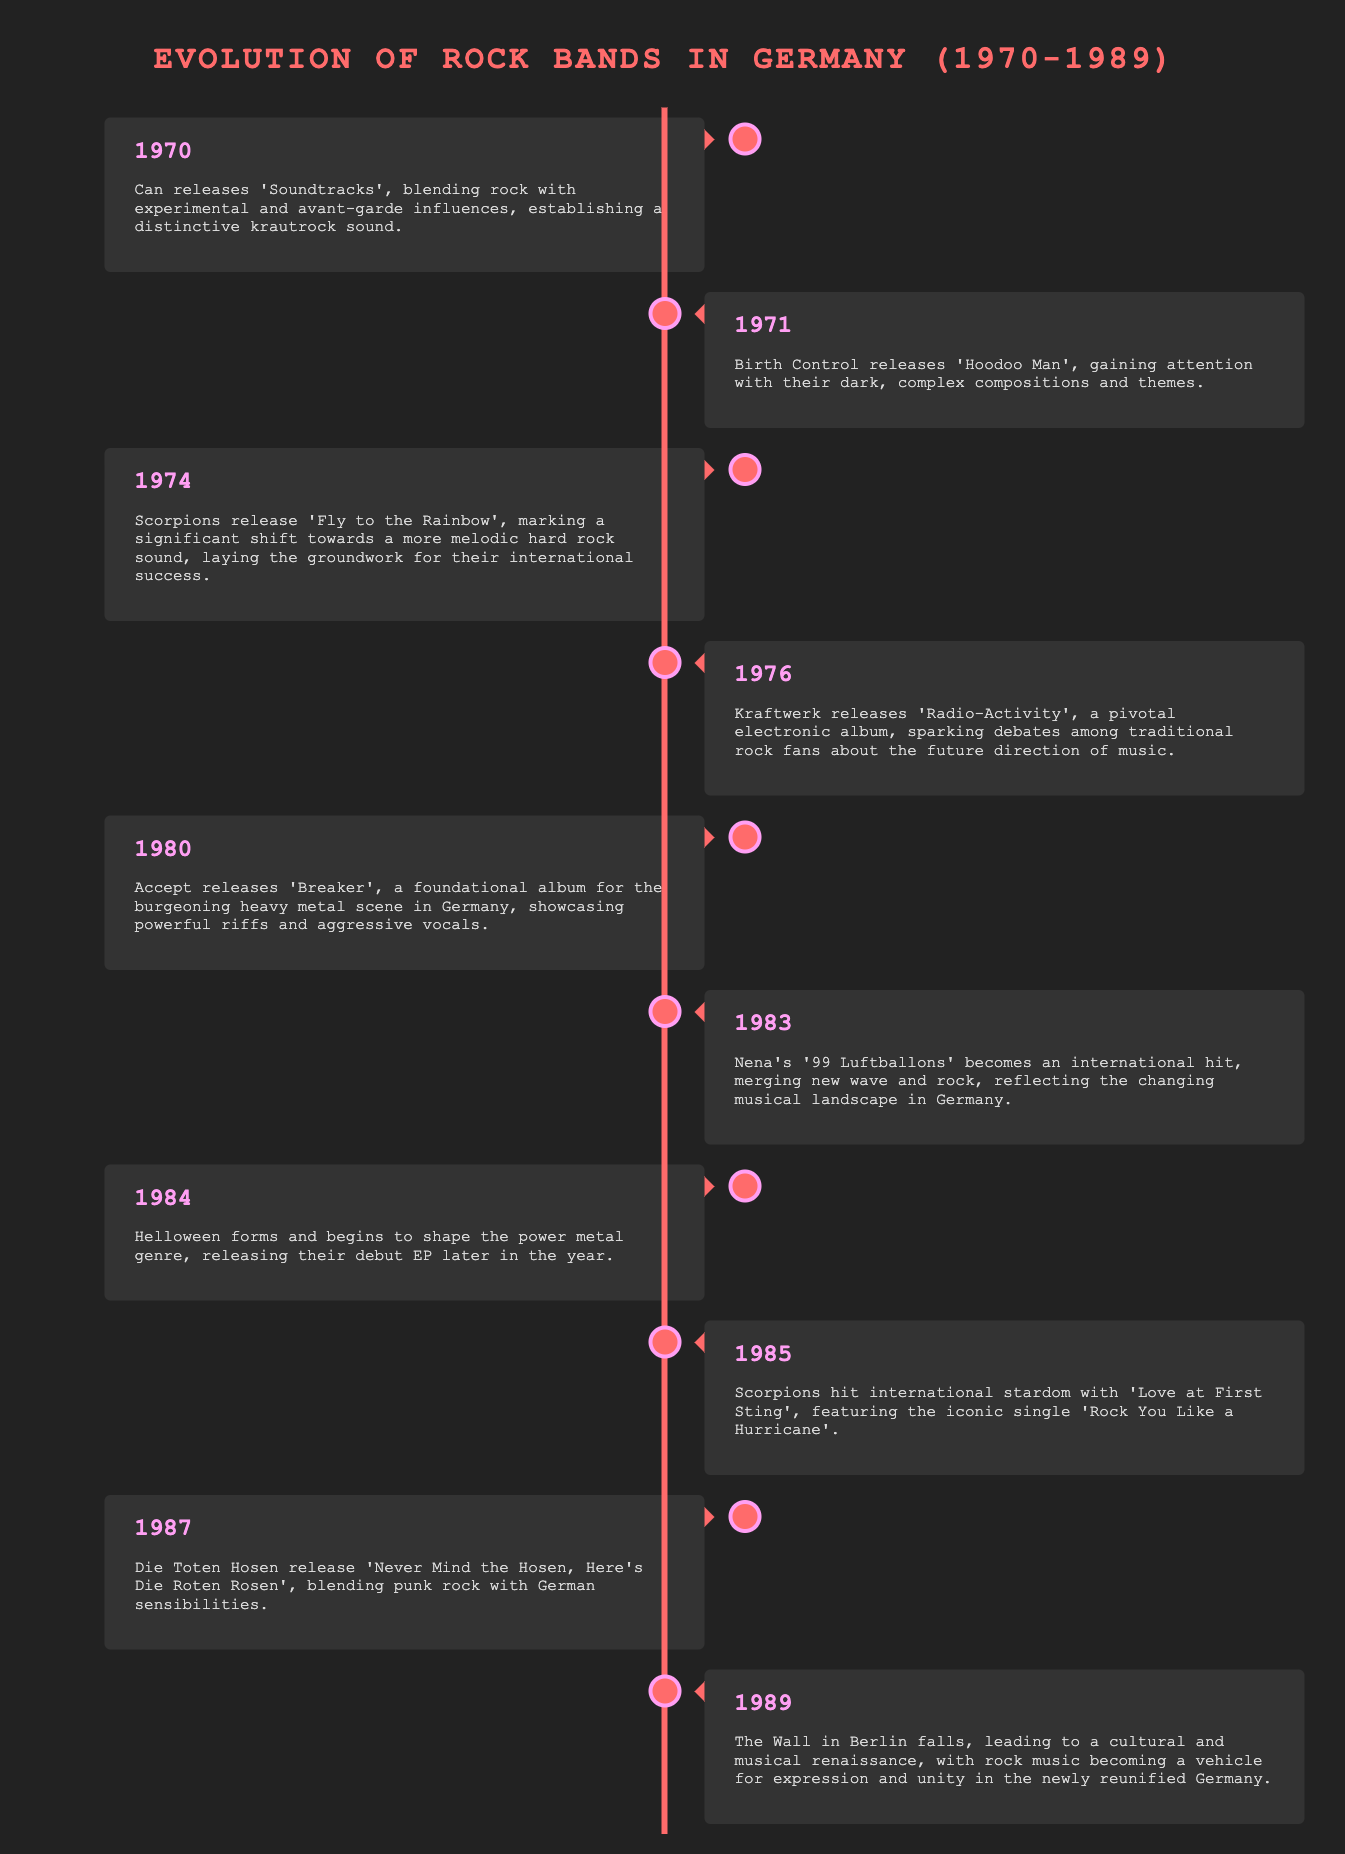What year did Can release 'Soundtracks'? The document states that Can released 'Soundtracks' in 1970.
Answer: 1970 What was the name of the album released by Scorpions in 1974? The timeline mentions that Scorpions released 'Fly to the Rainbow' in 1974.
Answer: Fly to the Rainbow Which band is associated with the 1980 album 'Breaker'? The document indicates that Accept released the album 'Breaker' in 1980.
Answer: Accept What is the significance of Kraftwerk's 1976 album 'Radio-Activity'? The document describes it as a pivotal electronic album sparking debates among traditional rock fans.
Answer: Pivotal electronic album In what year was '99 Luftballons' released? The timeline specifies that Nena's '99 Luftballons' became an international hit in 1983.
Answer: 1983 How did the fall of the Berlin Wall in 1989 impact rock music? The document states it led to a cultural and musical renaissance in Germany.
Answer: Cultural and musical renaissance Which genre did Helloween help to shape in 1984? The timeline indicates that Helloween began to shape the power metal genre.
Answer: Power metal What was a major theme in the 1971 album 'Hoodoo Man' by Birth Control? The document mentions dark, complex compositions and themes.
Answer: Dark, complex compositions What key event happened in 1989 that influenced rock music in Germany? The timeline explains that the Wall in Berlin fell, leading to a renaissance in music.
Answer: The Wall in Berlin falls 